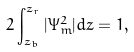<formula> <loc_0><loc_0><loc_500><loc_500>2 \int _ { z _ { b } } ^ { z _ { r } } | \Psi _ { m } ^ { 2 } | d z = 1 ,</formula> 